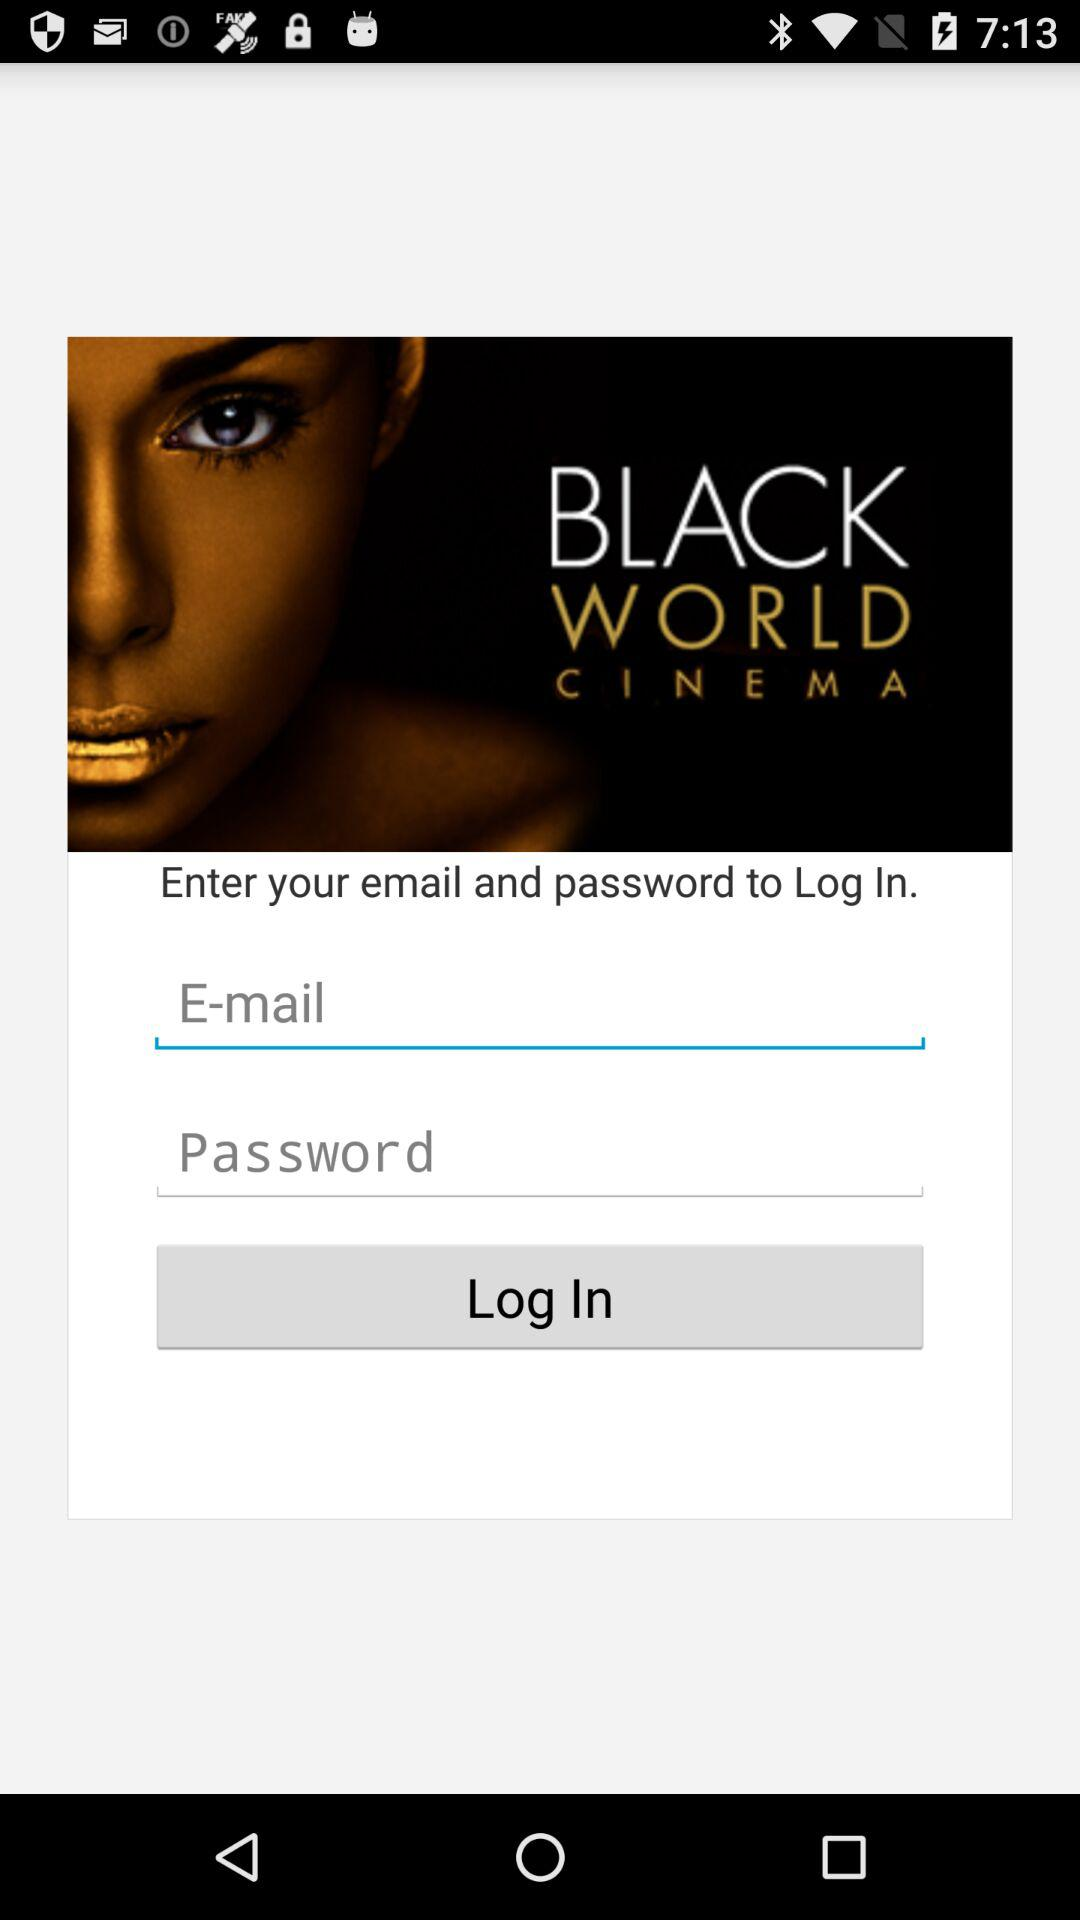What is the name of the application? The name of the application is "BLACK WORLD CINEMA". 